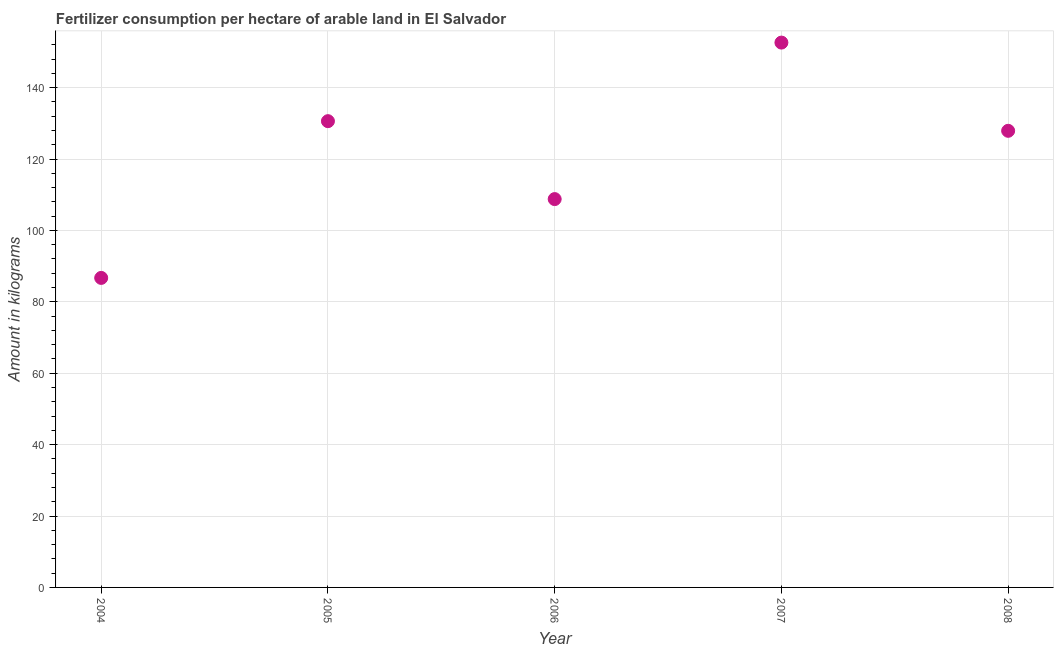What is the amount of fertilizer consumption in 2007?
Give a very brief answer. 152.61. Across all years, what is the maximum amount of fertilizer consumption?
Your answer should be very brief. 152.61. Across all years, what is the minimum amount of fertilizer consumption?
Keep it short and to the point. 86.7. In which year was the amount of fertilizer consumption maximum?
Ensure brevity in your answer.  2007. In which year was the amount of fertilizer consumption minimum?
Provide a short and direct response. 2004. What is the sum of the amount of fertilizer consumption?
Offer a terse response. 606.58. What is the difference between the amount of fertilizer consumption in 2004 and 2005?
Give a very brief answer. -43.9. What is the average amount of fertilizer consumption per year?
Give a very brief answer. 121.32. What is the median amount of fertilizer consumption?
Your answer should be compact. 127.9. Do a majority of the years between 2006 and 2007 (inclusive) have amount of fertilizer consumption greater than 112 kg?
Provide a succinct answer. No. What is the ratio of the amount of fertilizer consumption in 2005 to that in 2007?
Your answer should be compact. 0.86. Is the amount of fertilizer consumption in 2004 less than that in 2007?
Make the answer very short. Yes. Is the difference between the amount of fertilizer consumption in 2004 and 2006 greater than the difference between any two years?
Provide a short and direct response. No. What is the difference between the highest and the second highest amount of fertilizer consumption?
Your answer should be very brief. 22.01. What is the difference between the highest and the lowest amount of fertilizer consumption?
Provide a short and direct response. 65.91. In how many years, is the amount of fertilizer consumption greater than the average amount of fertilizer consumption taken over all years?
Ensure brevity in your answer.  3. Does the amount of fertilizer consumption monotonically increase over the years?
Your response must be concise. No. How many dotlines are there?
Your response must be concise. 1. How many years are there in the graph?
Offer a terse response. 5. What is the difference between two consecutive major ticks on the Y-axis?
Your response must be concise. 20. Does the graph contain any zero values?
Your answer should be very brief. No. Does the graph contain grids?
Make the answer very short. Yes. What is the title of the graph?
Provide a short and direct response. Fertilizer consumption per hectare of arable land in El Salvador . What is the label or title of the X-axis?
Give a very brief answer. Year. What is the label or title of the Y-axis?
Your answer should be very brief. Amount in kilograms. What is the Amount in kilograms in 2004?
Provide a short and direct response. 86.7. What is the Amount in kilograms in 2005?
Your answer should be very brief. 130.6. What is the Amount in kilograms in 2006?
Ensure brevity in your answer.  108.77. What is the Amount in kilograms in 2007?
Your response must be concise. 152.61. What is the Amount in kilograms in 2008?
Offer a very short reply. 127.9. What is the difference between the Amount in kilograms in 2004 and 2005?
Your response must be concise. -43.9. What is the difference between the Amount in kilograms in 2004 and 2006?
Offer a very short reply. -22.08. What is the difference between the Amount in kilograms in 2004 and 2007?
Keep it short and to the point. -65.91. What is the difference between the Amount in kilograms in 2004 and 2008?
Offer a very short reply. -41.2. What is the difference between the Amount in kilograms in 2005 and 2006?
Provide a succinct answer. 21.83. What is the difference between the Amount in kilograms in 2005 and 2007?
Offer a very short reply. -22.01. What is the difference between the Amount in kilograms in 2005 and 2008?
Provide a short and direct response. 2.7. What is the difference between the Amount in kilograms in 2006 and 2007?
Your answer should be very brief. -43.84. What is the difference between the Amount in kilograms in 2006 and 2008?
Give a very brief answer. -19.13. What is the difference between the Amount in kilograms in 2007 and 2008?
Offer a very short reply. 24.71. What is the ratio of the Amount in kilograms in 2004 to that in 2005?
Your response must be concise. 0.66. What is the ratio of the Amount in kilograms in 2004 to that in 2006?
Your answer should be very brief. 0.8. What is the ratio of the Amount in kilograms in 2004 to that in 2007?
Offer a very short reply. 0.57. What is the ratio of the Amount in kilograms in 2004 to that in 2008?
Offer a very short reply. 0.68. What is the ratio of the Amount in kilograms in 2005 to that in 2006?
Provide a succinct answer. 1.2. What is the ratio of the Amount in kilograms in 2005 to that in 2007?
Make the answer very short. 0.86. What is the ratio of the Amount in kilograms in 2006 to that in 2007?
Provide a short and direct response. 0.71. What is the ratio of the Amount in kilograms in 2007 to that in 2008?
Give a very brief answer. 1.19. 